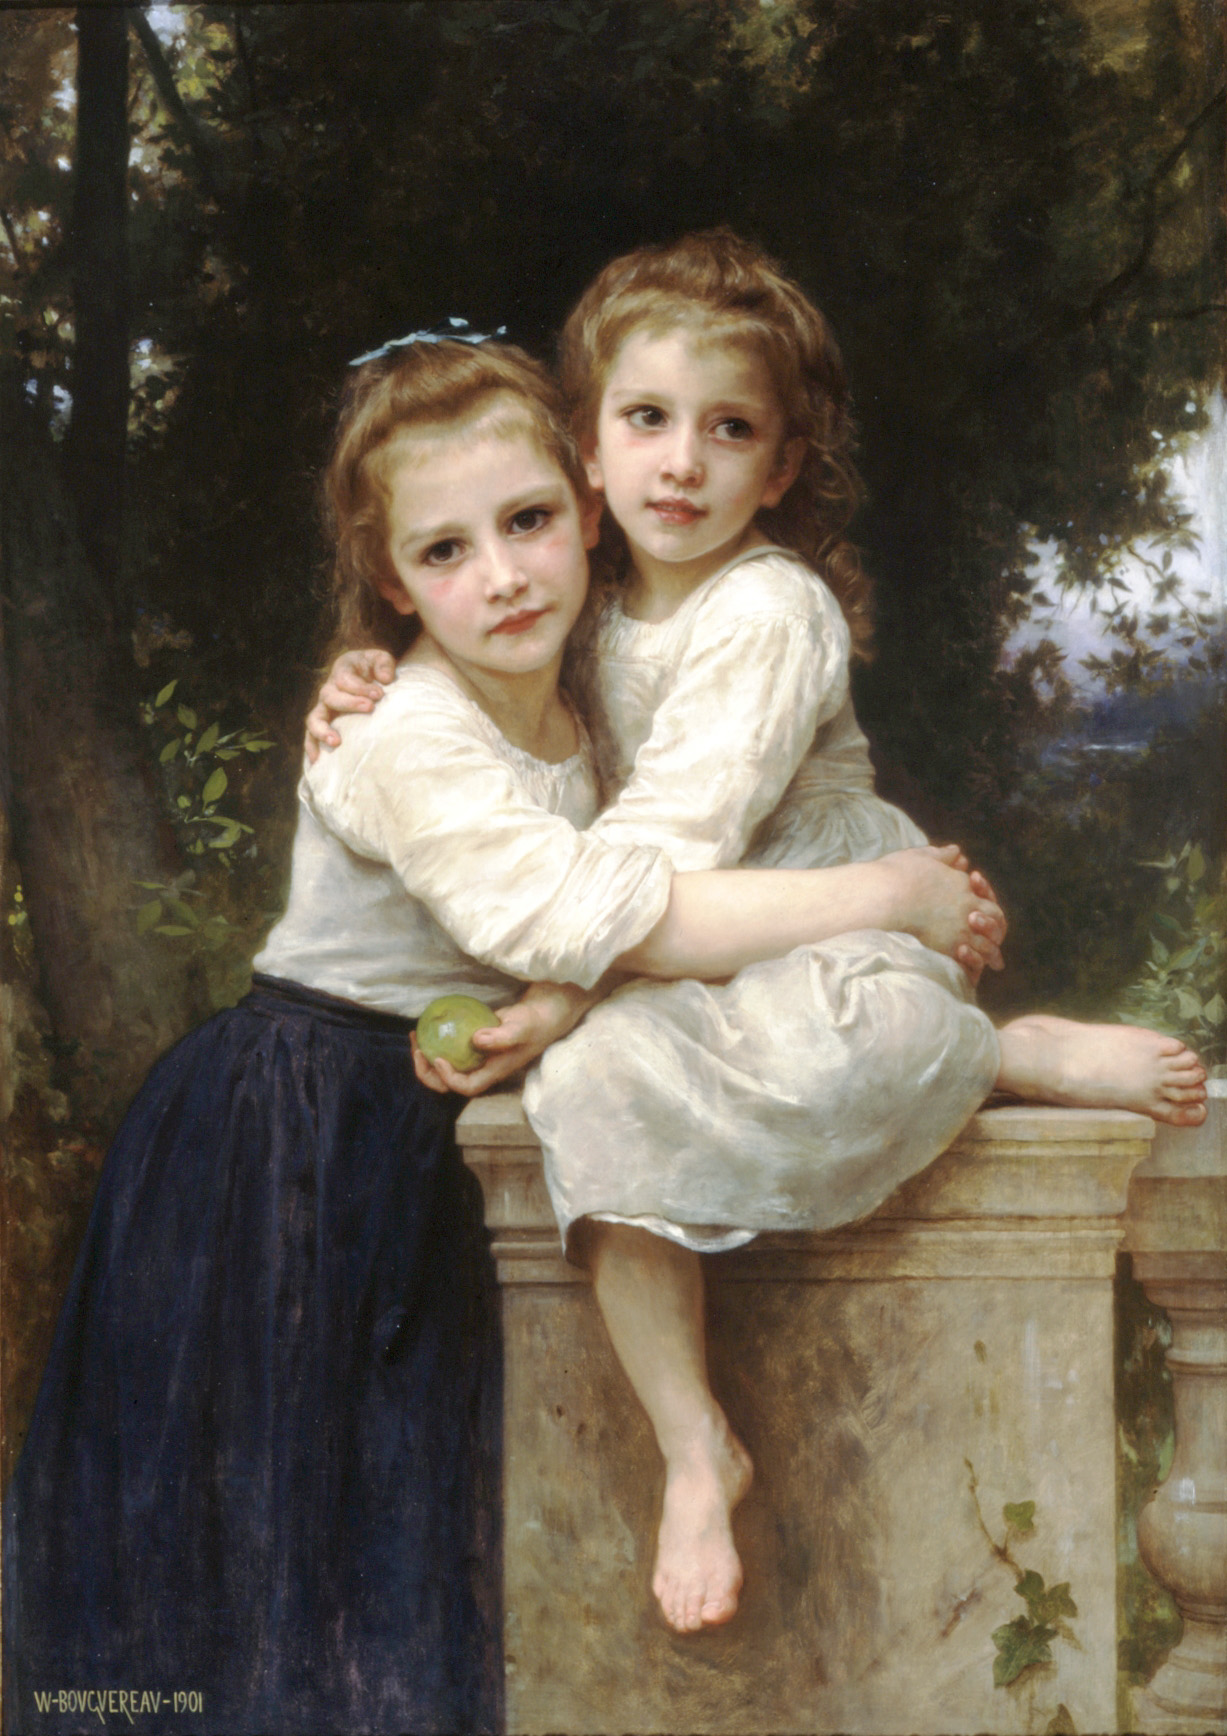What might the green apple in the girl's hand symbolize in this painting? The green apple in the girl's hand could symbolize youth and innocence, aligning with the overall aura of fresh, innocent childhood depicted in the image. It may also represent a sort of quiet pleasure or simple joys in life, accentuating the theme of serene contentment present in the scene. 